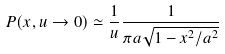<formula> <loc_0><loc_0><loc_500><loc_500>P ( x , u \rightarrow 0 ) \simeq \frac { 1 } { u } \frac { 1 } { \pi a \sqrt { 1 - x ^ { 2 } / a ^ { 2 } } }</formula> 